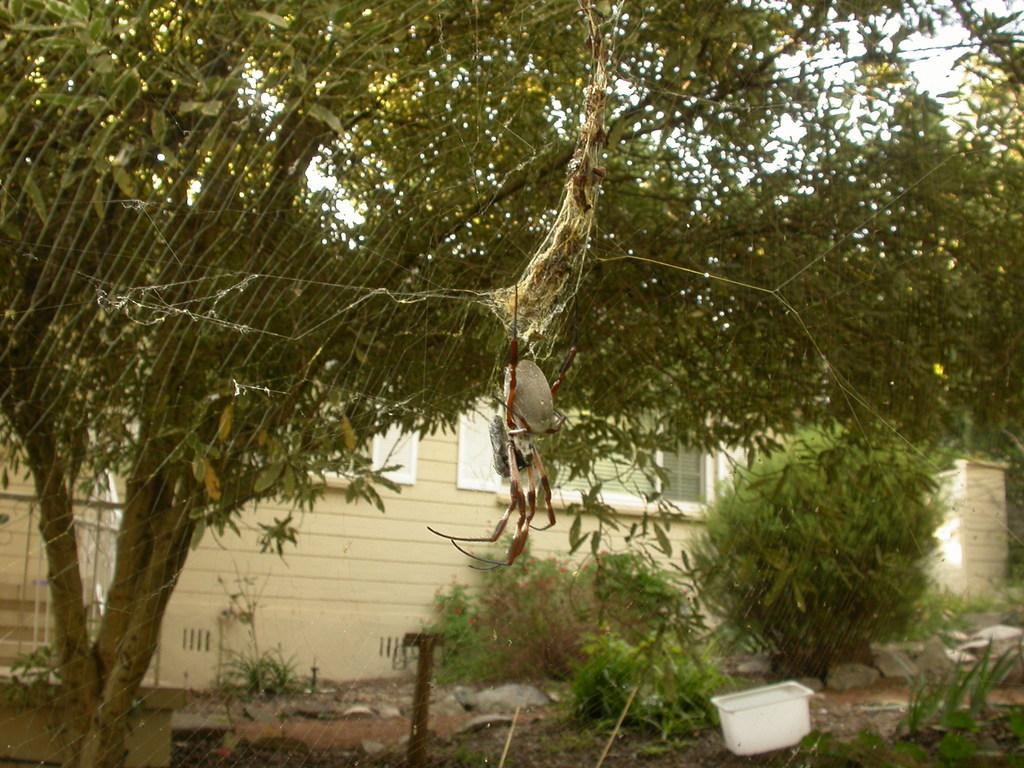Can you describe this image briefly? In the picture there is a web of an insect and behind that there are many trees and in the background there is a house. 